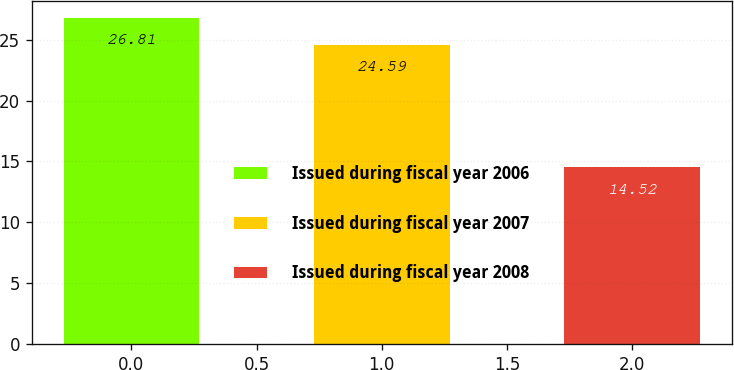Convert chart to OTSL. <chart><loc_0><loc_0><loc_500><loc_500><bar_chart><fcel>Issued during fiscal year 2006<fcel>Issued during fiscal year 2007<fcel>Issued during fiscal year 2008<nl><fcel>26.81<fcel>24.59<fcel>14.52<nl></chart> 